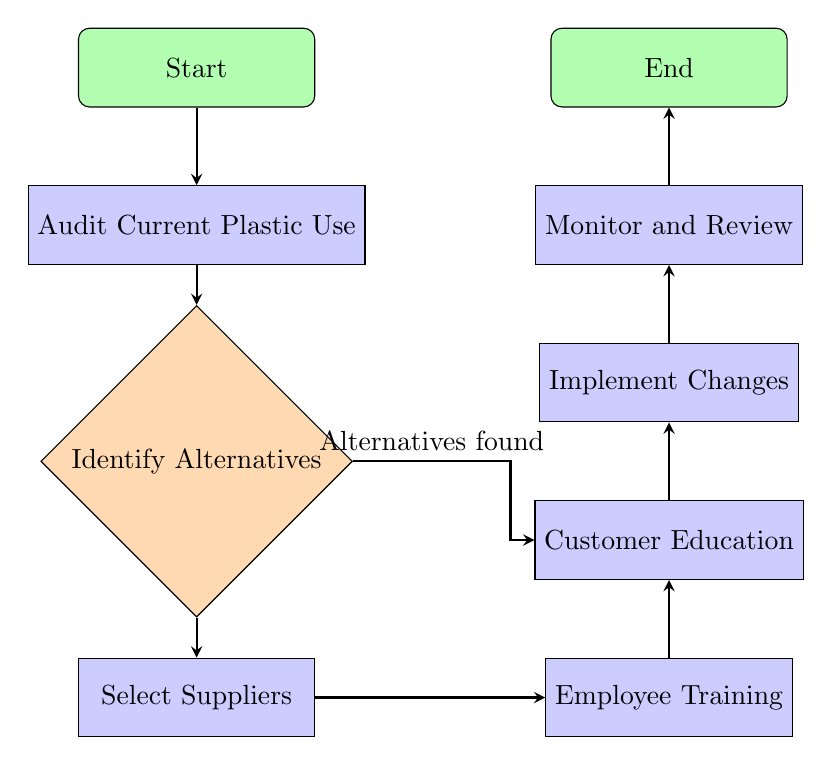What is the first step in the plastic reduction plan? The first node in the flow chart, labeled "Start," indicates the initiation of the plastic reduction plan.
Answer: Start How many processes are there in the diagram? There are five process nodes in the flow chart: "Audit Current Plastic Use," "Select Suppliers," "Employee Training," "Customer Education," and "Implement Changes."
Answer: 5 Which step comes after "Identify Alternatives"? According to the diagram, the step that follows "Identify Alternatives" is "Select Suppliers."
Answer: Select Suppliers What type of decision does the "Identify Alternatives" node represent? The "Identify Alternatives" node is structured as a diamond shape, indicating it is a decision point in the flow.
Answer: Decision Which two processes are directly connected to "Select Suppliers"? The "Select Suppliers" process is directly linked to "Identify Alternatives," and it also connects to "Employee Training."
Answer: Employee Training What happens if alternatives are found during the "Identify Alternatives" step? If alternatives are found, the flow chart illustrates that it leads to the "Customer Education" process through a rightward decision.
Answer: Customer Education How many total nodes are present in the flow chart? The flow chart consists of a total of nine nodes, including start, processes, decision, and end points.
Answer: 9 What is the final process before concluding the plan? The last process before reaching the "End" node is "Monitor and Review."
Answer: Monitor and Review 